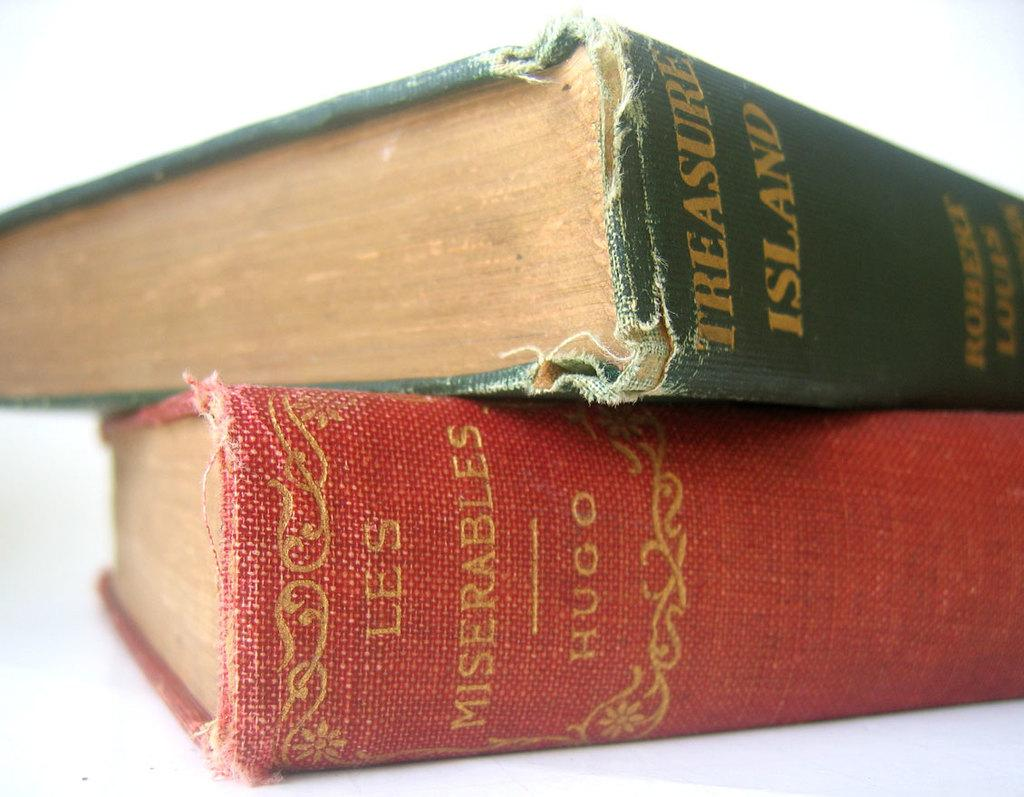Provide a one-sentence caption for the provided image. The classic book Treasure Island lies atop the Hugo classic called Les Miserables. 